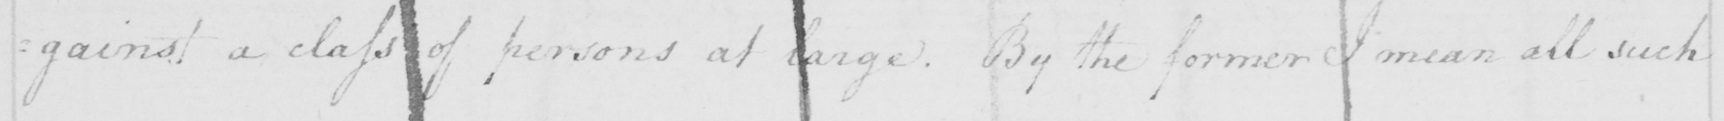Transcribe the text shown in this historical manuscript line. =gainst a class of persons at large . By the former I mean all such 